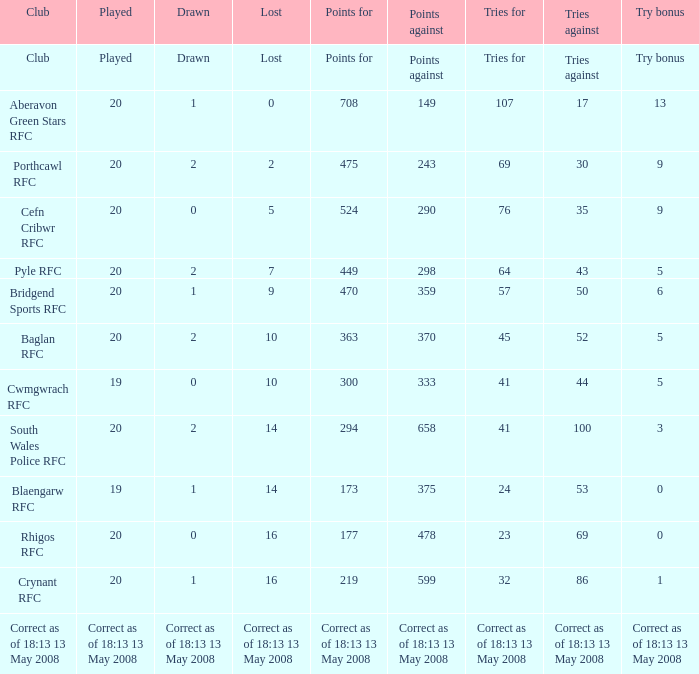What is the tries for when 52 was the tries against? 45.0. 